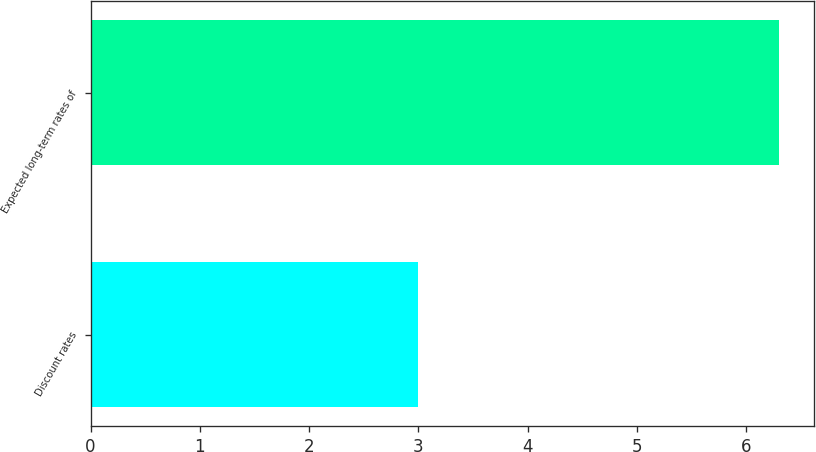<chart> <loc_0><loc_0><loc_500><loc_500><bar_chart><fcel>Discount rates<fcel>Expected long-term rates of<nl><fcel>3<fcel>6.3<nl></chart> 